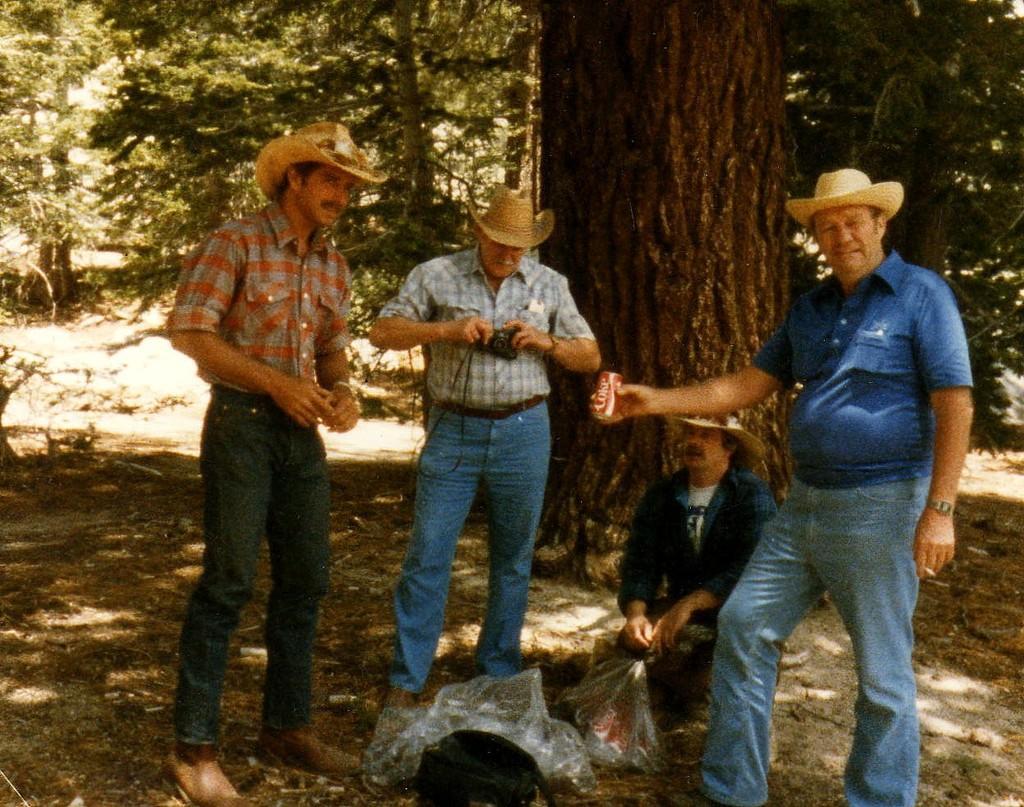How would you summarize this image in a sentence or two? In this image we can see four persons, among them, two persons are holding the objects, in the background, we can see the trees and also we can see a bag and some objects on the ground. 